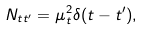<formula> <loc_0><loc_0><loc_500><loc_500>N _ { t t ^ { \prime } } = \mu _ { t } ^ { 2 } \delta ( t - t ^ { \prime } ) ,</formula> 